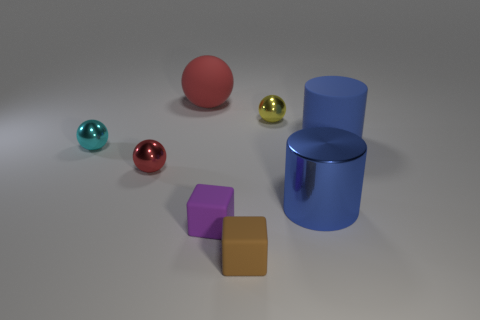There is a thing that is both behind the big rubber cylinder and to the right of the large sphere; what is its shape?
Keep it short and to the point. Sphere. How many big blue cylinders have the same material as the small brown block?
Offer a very short reply. 1. How many purple rubber things are behind the small metallic object that is behind the small cyan sphere?
Keep it short and to the point. 0. There is a blue object that is to the right of the blue thing that is left of the large rubber thing that is in front of the tiny yellow object; what shape is it?
Your response must be concise. Cylinder. There is a rubber cylinder that is the same color as the big metallic object; what is its size?
Make the answer very short. Large. How many things are green rubber blocks or big matte objects?
Your answer should be compact. 2. The other cylinder that is the same size as the blue rubber cylinder is what color?
Your response must be concise. Blue. Does the big shiny object have the same shape as the big blue thing that is behind the small cyan object?
Ensure brevity in your answer.  Yes. How many objects are cubes that are on the left side of the brown block or objects that are to the left of the red shiny sphere?
Make the answer very short. 2. There is a large thing that is the same color as the large metallic cylinder; what is its shape?
Provide a succinct answer. Cylinder. 